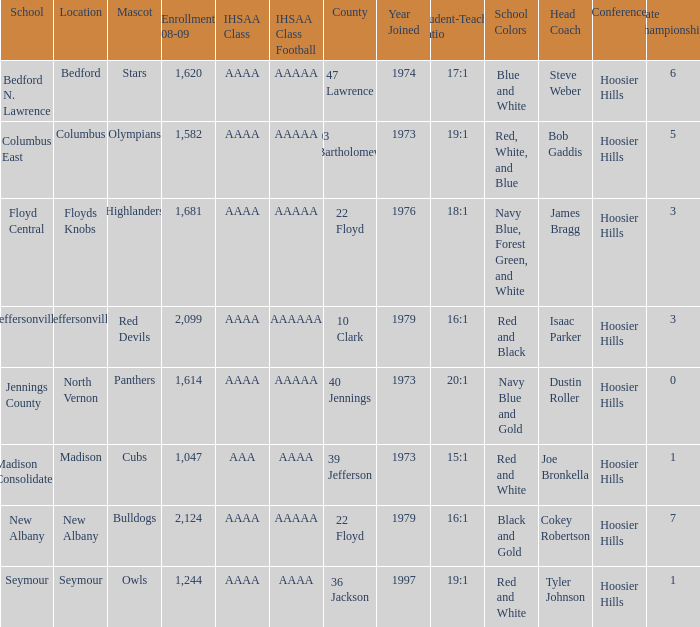What's the IHSAA Class when the school is Seymour? AAAA. 